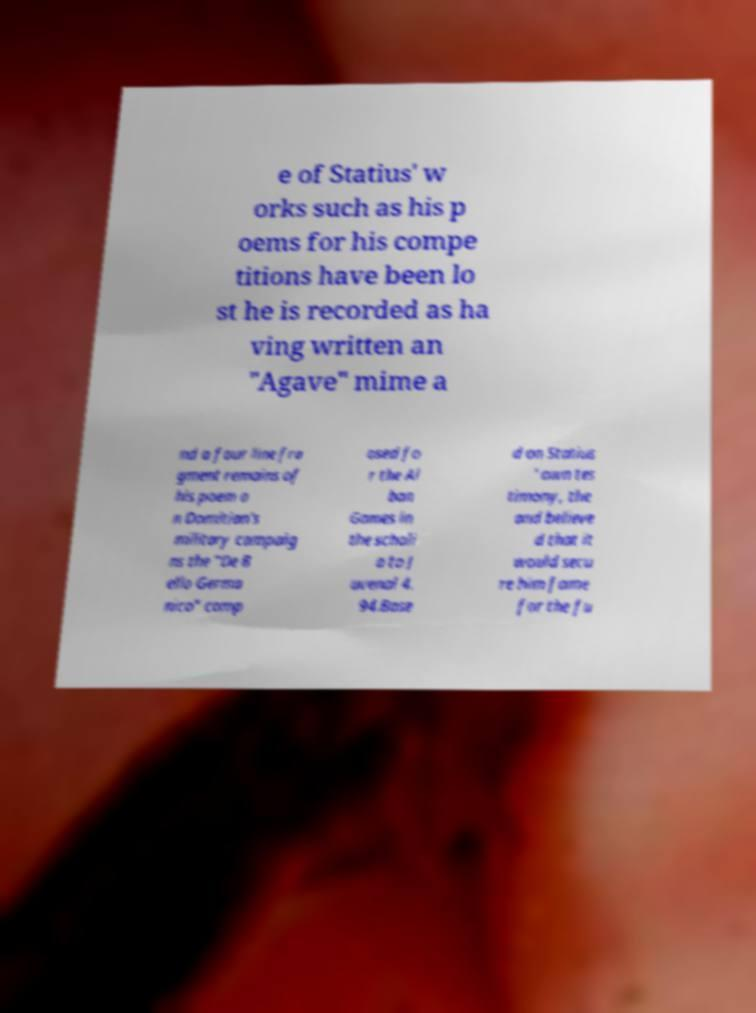Could you extract and type out the text from this image? e of Statius' w orks such as his p oems for his compe titions have been lo st he is recorded as ha ving written an "Agave" mime a nd a four line fra gment remains of his poem o n Domitian's military campaig ns the "De B ello Germa nico" comp osed fo r the Al ban Games in the scholi a to J uvenal 4. 94.Base d on Statius ' own tes timony, the and believe d that it would secu re him fame for the fu 